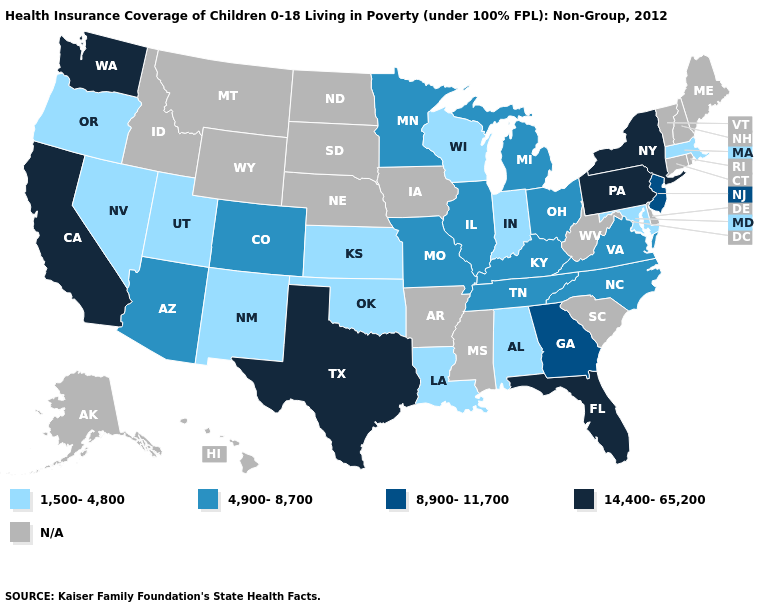Name the states that have a value in the range 4,900-8,700?
Concise answer only. Arizona, Colorado, Illinois, Kentucky, Michigan, Minnesota, Missouri, North Carolina, Ohio, Tennessee, Virginia. What is the value of Tennessee?
Answer briefly. 4,900-8,700. Does Wisconsin have the lowest value in the MidWest?
Write a very short answer. Yes. Name the states that have a value in the range 14,400-65,200?
Write a very short answer. California, Florida, New York, Pennsylvania, Texas, Washington. Among the states that border New York , which have the lowest value?
Keep it brief. Massachusetts. What is the value of Vermont?
Keep it brief. N/A. What is the value of Arizona?
Write a very short answer. 4,900-8,700. What is the lowest value in the MidWest?
Keep it brief. 1,500-4,800. What is the lowest value in the USA?
Write a very short answer. 1,500-4,800. What is the highest value in the USA?
Be succinct. 14,400-65,200. Name the states that have a value in the range 1,500-4,800?
Quick response, please. Alabama, Indiana, Kansas, Louisiana, Maryland, Massachusetts, Nevada, New Mexico, Oklahoma, Oregon, Utah, Wisconsin. What is the value of Tennessee?
Short answer required. 4,900-8,700. Among the states that border West Virginia , does Ohio have the lowest value?
Quick response, please. No. 